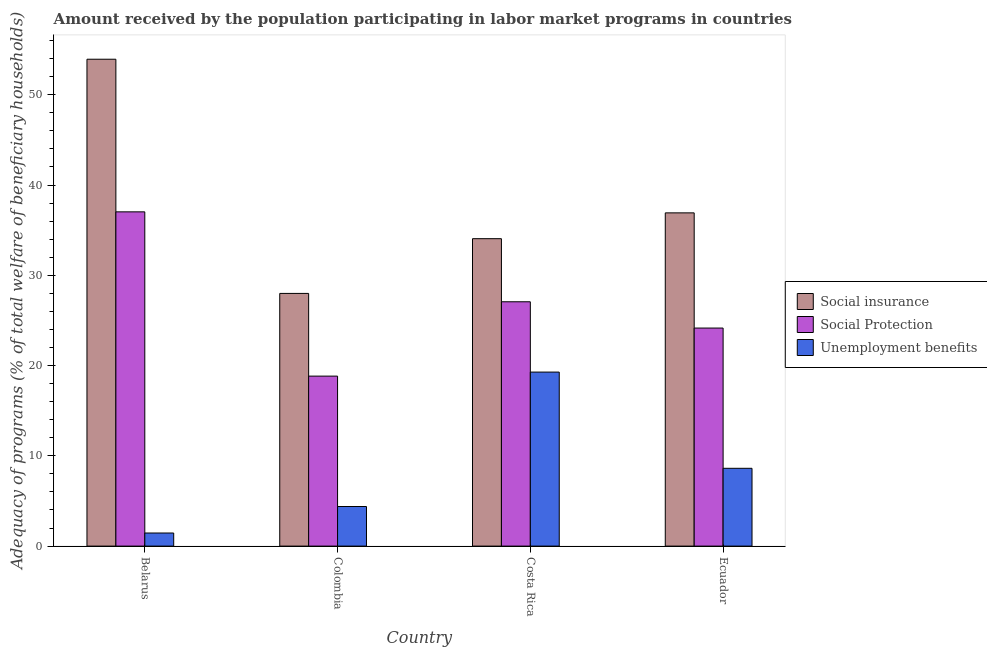How many different coloured bars are there?
Offer a very short reply. 3. How many groups of bars are there?
Your answer should be compact. 4. Are the number of bars per tick equal to the number of legend labels?
Offer a terse response. Yes. How many bars are there on the 2nd tick from the right?
Make the answer very short. 3. What is the label of the 1st group of bars from the left?
Your response must be concise. Belarus. What is the amount received by the population participating in social protection programs in Belarus?
Provide a succinct answer. 37.03. Across all countries, what is the maximum amount received by the population participating in social insurance programs?
Give a very brief answer. 53.93. Across all countries, what is the minimum amount received by the population participating in unemployment benefits programs?
Give a very brief answer. 1.45. In which country was the amount received by the population participating in social protection programs maximum?
Provide a short and direct response. Belarus. In which country was the amount received by the population participating in unemployment benefits programs minimum?
Provide a short and direct response. Belarus. What is the total amount received by the population participating in social insurance programs in the graph?
Your response must be concise. 152.89. What is the difference between the amount received by the population participating in social protection programs in Belarus and that in Ecuador?
Offer a very short reply. 12.87. What is the difference between the amount received by the population participating in social protection programs in Ecuador and the amount received by the population participating in social insurance programs in Belarus?
Provide a short and direct response. -29.78. What is the average amount received by the population participating in unemployment benefits programs per country?
Provide a succinct answer. 8.43. What is the difference between the amount received by the population participating in social protection programs and amount received by the population participating in social insurance programs in Costa Rica?
Your answer should be compact. -6.99. What is the ratio of the amount received by the population participating in social protection programs in Belarus to that in Colombia?
Provide a succinct answer. 1.97. Is the amount received by the population participating in social insurance programs in Belarus less than that in Colombia?
Offer a terse response. No. What is the difference between the highest and the second highest amount received by the population participating in unemployment benefits programs?
Your answer should be compact. 10.66. What is the difference between the highest and the lowest amount received by the population participating in social protection programs?
Keep it short and to the point. 18.2. Is the sum of the amount received by the population participating in unemployment benefits programs in Costa Rica and Ecuador greater than the maximum amount received by the population participating in social protection programs across all countries?
Keep it short and to the point. No. What does the 2nd bar from the left in Costa Rica represents?
Keep it short and to the point. Social Protection. What does the 1st bar from the right in Costa Rica represents?
Your answer should be compact. Unemployment benefits. Is it the case that in every country, the sum of the amount received by the population participating in social insurance programs and amount received by the population participating in social protection programs is greater than the amount received by the population participating in unemployment benefits programs?
Offer a very short reply. Yes. How many bars are there?
Your answer should be very brief. 12. What is the difference between two consecutive major ticks on the Y-axis?
Your answer should be compact. 10. Does the graph contain any zero values?
Your response must be concise. No. Does the graph contain grids?
Your answer should be very brief. No. Where does the legend appear in the graph?
Offer a terse response. Center right. How many legend labels are there?
Your response must be concise. 3. How are the legend labels stacked?
Provide a short and direct response. Vertical. What is the title of the graph?
Your answer should be very brief. Amount received by the population participating in labor market programs in countries. Does "Financial account" appear as one of the legend labels in the graph?
Your response must be concise. No. What is the label or title of the Y-axis?
Give a very brief answer. Adequacy of programs (% of total welfare of beneficiary households). What is the Adequacy of programs (% of total welfare of beneficiary households) in Social insurance in Belarus?
Your answer should be very brief. 53.93. What is the Adequacy of programs (% of total welfare of beneficiary households) in Social Protection in Belarus?
Provide a short and direct response. 37.03. What is the Adequacy of programs (% of total welfare of beneficiary households) in Unemployment benefits in Belarus?
Your response must be concise. 1.45. What is the Adequacy of programs (% of total welfare of beneficiary households) of Social insurance in Colombia?
Give a very brief answer. 27.99. What is the Adequacy of programs (% of total welfare of beneficiary households) in Social Protection in Colombia?
Provide a succinct answer. 18.83. What is the Adequacy of programs (% of total welfare of beneficiary households) in Unemployment benefits in Colombia?
Your answer should be compact. 4.39. What is the Adequacy of programs (% of total welfare of beneficiary households) of Social insurance in Costa Rica?
Keep it short and to the point. 34.05. What is the Adequacy of programs (% of total welfare of beneficiary households) of Social Protection in Costa Rica?
Your answer should be compact. 27.06. What is the Adequacy of programs (% of total welfare of beneficiary households) in Unemployment benefits in Costa Rica?
Make the answer very short. 19.28. What is the Adequacy of programs (% of total welfare of beneficiary households) in Social insurance in Ecuador?
Ensure brevity in your answer.  36.91. What is the Adequacy of programs (% of total welfare of beneficiary households) in Social Protection in Ecuador?
Your response must be concise. 24.15. What is the Adequacy of programs (% of total welfare of beneficiary households) in Unemployment benefits in Ecuador?
Keep it short and to the point. 8.62. Across all countries, what is the maximum Adequacy of programs (% of total welfare of beneficiary households) of Social insurance?
Provide a short and direct response. 53.93. Across all countries, what is the maximum Adequacy of programs (% of total welfare of beneficiary households) of Social Protection?
Offer a very short reply. 37.03. Across all countries, what is the maximum Adequacy of programs (% of total welfare of beneficiary households) of Unemployment benefits?
Give a very brief answer. 19.28. Across all countries, what is the minimum Adequacy of programs (% of total welfare of beneficiary households) of Social insurance?
Your answer should be compact. 27.99. Across all countries, what is the minimum Adequacy of programs (% of total welfare of beneficiary households) in Social Protection?
Offer a very short reply. 18.83. Across all countries, what is the minimum Adequacy of programs (% of total welfare of beneficiary households) in Unemployment benefits?
Make the answer very short. 1.45. What is the total Adequacy of programs (% of total welfare of beneficiary households) of Social insurance in the graph?
Your answer should be compact. 152.89. What is the total Adequacy of programs (% of total welfare of beneficiary households) of Social Protection in the graph?
Provide a short and direct response. 107.07. What is the total Adequacy of programs (% of total welfare of beneficiary households) in Unemployment benefits in the graph?
Keep it short and to the point. 33.73. What is the difference between the Adequacy of programs (% of total welfare of beneficiary households) in Social insurance in Belarus and that in Colombia?
Offer a very short reply. 25.94. What is the difference between the Adequacy of programs (% of total welfare of beneficiary households) of Social Protection in Belarus and that in Colombia?
Your answer should be compact. 18.2. What is the difference between the Adequacy of programs (% of total welfare of beneficiary households) of Unemployment benefits in Belarus and that in Colombia?
Your answer should be very brief. -2.94. What is the difference between the Adequacy of programs (% of total welfare of beneficiary households) of Social insurance in Belarus and that in Costa Rica?
Your response must be concise. 19.88. What is the difference between the Adequacy of programs (% of total welfare of beneficiary households) of Social Protection in Belarus and that in Costa Rica?
Offer a very short reply. 9.96. What is the difference between the Adequacy of programs (% of total welfare of beneficiary households) in Unemployment benefits in Belarus and that in Costa Rica?
Your answer should be compact. -17.83. What is the difference between the Adequacy of programs (% of total welfare of beneficiary households) of Social insurance in Belarus and that in Ecuador?
Provide a succinct answer. 17.02. What is the difference between the Adequacy of programs (% of total welfare of beneficiary households) of Social Protection in Belarus and that in Ecuador?
Give a very brief answer. 12.87. What is the difference between the Adequacy of programs (% of total welfare of beneficiary households) in Unemployment benefits in Belarus and that in Ecuador?
Provide a succinct answer. -7.17. What is the difference between the Adequacy of programs (% of total welfare of beneficiary households) of Social insurance in Colombia and that in Costa Rica?
Offer a terse response. -6.06. What is the difference between the Adequacy of programs (% of total welfare of beneficiary households) in Social Protection in Colombia and that in Costa Rica?
Give a very brief answer. -8.24. What is the difference between the Adequacy of programs (% of total welfare of beneficiary households) in Unemployment benefits in Colombia and that in Costa Rica?
Make the answer very short. -14.89. What is the difference between the Adequacy of programs (% of total welfare of beneficiary households) in Social insurance in Colombia and that in Ecuador?
Offer a very short reply. -8.92. What is the difference between the Adequacy of programs (% of total welfare of beneficiary households) of Social Protection in Colombia and that in Ecuador?
Offer a terse response. -5.33. What is the difference between the Adequacy of programs (% of total welfare of beneficiary households) in Unemployment benefits in Colombia and that in Ecuador?
Your response must be concise. -4.23. What is the difference between the Adequacy of programs (% of total welfare of beneficiary households) of Social insurance in Costa Rica and that in Ecuador?
Keep it short and to the point. -2.86. What is the difference between the Adequacy of programs (% of total welfare of beneficiary households) of Social Protection in Costa Rica and that in Ecuador?
Provide a succinct answer. 2.91. What is the difference between the Adequacy of programs (% of total welfare of beneficiary households) of Unemployment benefits in Costa Rica and that in Ecuador?
Keep it short and to the point. 10.66. What is the difference between the Adequacy of programs (% of total welfare of beneficiary households) of Social insurance in Belarus and the Adequacy of programs (% of total welfare of beneficiary households) of Social Protection in Colombia?
Offer a very short reply. 35.1. What is the difference between the Adequacy of programs (% of total welfare of beneficiary households) of Social insurance in Belarus and the Adequacy of programs (% of total welfare of beneficiary households) of Unemployment benefits in Colombia?
Ensure brevity in your answer.  49.55. What is the difference between the Adequacy of programs (% of total welfare of beneficiary households) of Social Protection in Belarus and the Adequacy of programs (% of total welfare of beneficiary households) of Unemployment benefits in Colombia?
Ensure brevity in your answer.  32.64. What is the difference between the Adequacy of programs (% of total welfare of beneficiary households) in Social insurance in Belarus and the Adequacy of programs (% of total welfare of beneficiary households) in Social Protection in Costa Rica?
Make the answer very short. 26.87. What is the difference between the Adequacy of programs (% of total welfare of beneficiary households) of Social insurance in Belarus and the Adequacy of programs (% of total welfare of beneficiary households) of Unemployment benefits in Costa Rica?
Provide a short and direct response. 34.66. What is the difference between the Adequacy of programs (% of total welfare of beneficiary households) of Social Protection in Belarus and the Adequacy of programs (% of total welfare of beneficiary households) of Unemployment benefits in Costa Rica?
Offer a terse response. 17.75. What is the difference between the Adequacy of programs (% of total welfare of beneficiary households) in Social insurance in Belarus and the Adequacy of programs (% of total welfare of beneficiary households) in Social Protection in Ecuador?
Offer a very short reply. 29.78. What is the difference between the Adequacy of programs (% of total welfare of beneficiary households) of Social insurance in Belarus and the Adequacy of programs (% of total welfare of beneficiary households) of Unemployment benefits in Ecuador?
Your answer should be compact. 45.32. What is the difference between the Adequacy of programs (% of total welfare of beneficiary households) of Social Protection in Belarus and the Adequacy of programs (% of total welfare of beneficiary households) of Unemployment benefits in Ecuador?
Provide a succinct answer. 28.41. What is the difference between the Adequacy of programs (% of total welfare of beneficiary households) in Social insurance in Colombia and the Adequacy of programs (% of total welfare of beneficiary households) in Social Protection in Costa Rica?
Offer a very short reply. 0.93. What is the difference between the Adequacy of programs (% of total welfare of beneficiary households) of Social insurance in Colombia and the Adequacy of programs (% of total welfare of beneficiary households) of Unemployment benefits in Costa Rica?
Your answer should be compact. 8.72. What is the difference between the Adequacy of programs (% of total welfare of beneficiary households) of Social Protection in Colombia and the Adequacy of programs (% of total welfare of beneficiary households) of Unemployment benefits in Costa Rica?
Provide a short and direct response. -0.45. What is the difference between the Adequacy of programs (% of total welfare of beneficiary households) in Social insurance in Colombia and the Adequacy of programs (% of total welfare of beneficiary households) in Social Protection in Ecuador?
Provide a short and direct response. 3.84. What is the difference between the Adequacy of programs (% of total welfare of beneficiary households) of Social insurance in Colombia and the Adequacy of programs (% of total welfare of beneficiary households) of Unemployment benefits in Ecuador?
Give a very brief answer. 19.37. What is the difference between the Adequacy of programs (% of total welfare of beneficiary households) of Social Protection in Colombia and the Adequacy of programs (% of total welfare of beneficiary households) of Unemployment benefits in Ecuador?
Provide a succinct answer. 10.21. What is the difference between the Adequacy of programs (% of total welfare of beneficiary households) in Social insurance in Costa Rica and the Adequacy of programs (% of total welfare of beneficiary households) in Social Protection in Ecuador?
Offer a very short reply. 9.9. What is the difference between the Adequacy of programs (% of total welfare of beneficiary households) of Social insurance in Costa Rica and the Adequacy of programs (% of total welfare of beneficiary households) of Unemployment benefits in Ecuador?
Ensure brevity in your answer.  25.44. What is the difference between the Adequacy of programs (% of total welfare of beneficiary households) of Social Protection in Costa Rica and the Adequacy of programs (% of total welfare of beneficiary households) of Unemployment benefits in Ecuador?
Offer a very short reply. 18.45. What is the average Adequacy of programs (% of total welfare of beneficiary households) in Social insurance per country?
Your answer should be very brief. 38.22. What is the average Adequacy of programs (% of total welfare of beneficiary households) of Social Protection per country?
Your answer should be compact. 26.77. What is the average Adequacy of programs (% of total welfare of beneficiary households) of Unemployment benefits per country?
Offer a terse response. 8.43. What is the difference between the Adequacy of programs (% of total welfare of beneficiary households) in Social insurance and Adequacy of programs (% of total welfare of beneficiary households) in Social Protection in Belarus?
Give a very brief answer. 16.91. What is the difference between the Adequacy of programs (% of total welfare of beneficiary households) of Social insurance and Adequacy of programs (% of total welfare of beneficiary households) of Unemployment benefits in Belarus?
Give a very brief answer. 52.48. What is the difference between the Adequacy of programs (% of total welfare of beneficiary households) in Social Protection and Adequacy of programs (% of total welfare of beneficiary households) in Unemployment benefits in Belarus?
Provide a short and direct response. 35.58. What is the difference between the Adequacy of programs (% of total welfare of beneficiary households) of Social insurance and Adequacy of programs (% of total welfare of beneficiary households) of Social Protection in Colombia?
Your response must be concise. 9.16. What is the difference between the Adequacy of programs (% of total welfare of beneficiary households) of Social insurance and Adequacy of programs (% of total welfare of beneficiary households) of Unemployment benefits in Colombia?
Ensure brevity in your answer.  23.61. What is the difference between the Adequacy of programs (% of total welfare of beneficiary households) in Social Protection and Adequacy of programs (% of total welfare of beneficiary households) in Unemployment benefits in Colombia?
Your answer should be very brief. 14.44. What is the difference between the Adequacy of programs (% of total welfare of beneficiary households) of Social insurance and Adequacy of programs (% of total welfare of beneficiary households) of Social Protection in Costa Rica?
Keep it short and to the point. 6.99. What is the difference between the Adequacy of programs (% of total welfare of beneficiary households) in Social insurance and Adequacy of programs (% of total welfare of beneficiary households) in Unemployment benefits in Costa Rica?
Ensure brevity in your answer.  14.78. What is the difference between the Adequacy of programs (% of total welfare of beneficiary households) of Social Protection and Adequacy of programs (% of total welfare of beneficiary households) of Unemployment benefits in Costa Rica?
Give a very brief answer. 7.79. What is the difference between the Adequacy of programs (% of total welfare of beneficiary households) in Social insurance and Adequacy of programs (% of total welfare of beneficiary households) in Social Protection in Ecuador?
Provide a succinct answer. 12.76. What is the difference between the Adequacy of programs (% of total welfare of beneficiary households) of Social insurance and Adequacy of programs (% of total welfare of beneficiary households) of Unemployment benefits in Ecuador?
Your response must be concise. 28.3. What is the difference between the Adequacy of programs (% of total welfare of beneficiary households) of Social Protection and Adequacy of programs (% of total welfare of beneficiary households) of Unemployment benefits in Ecuador?
Your answer should be very brief. 15.54. What is the ratio of the Adequacy of programs (% of total welfare of beneficiary households) in Social insurance in Belarus to that in Colombia?
Your response must be concise. 1.93. What is the ratio of the Adequacy of programs (% of total welfare of beneficiary households) in Social Protection in Belarus to that in Colombia?
Your answer should be very brief. 1.97. What is the ratio of the Adequacy of programs (% of total welfare of beneficiary households) in Unemployment benefits in Belarus to that in Colombia?
Provide a short and direct response. 0.33. What is the ratio of the Adequacy of programs (% of total welfare of beneficiary households) in Social insurance in Belarus to that in Costa Rica?
Make the answer very short. 1.58. What is the ratio of the Adequacy of programs (% of total welfare of beneficiary households) of Social Protection in Belarus to that in Costa Rica?
Give a very brief answer. 1.37. What is the ratio of the Adequacy of programs (% of total welfare of beneficiary households) in Unemployment benefits in Belarus to that in Costa Rica?
Ensure brevity in your answer.  0.08. What is the ratio of the Adequacy of programs (% of total welfare of beneficiary households) in Social insurance in Belarus to that in Ecuador?
Provide a succinct answer. 1.46. What is the ratio of the Adequacy of programs (% of total welfare of beneficiary households) of Social Protection in Belarus to that in Ecuador?
Your answer should be compact. 1.53. What is the ratio of the Adequacy of programs (% of total welfare of beneficiary households) in Unemployment benefits in Belarus to that in Ecuador?
Your answer should be very brief. 0.17. What is the ratio of the Adequacy of programs (% of total welfare of beneficiary households) of Social insurance in Colombia to that in Costa Rica?
Provide a succinct answer. 0.82. What is the ratio of the Adequacy of programs (% of total welfare of beneficiary households) of Social Protection in Colombia to that in Costa Rica?
Ensure brevity in your answer.  0.7. What is the ratio of the Adequacy of programs (% of total welfare of beneficiary households) of Unemployment benefits in Colombia to that in Costa Rica?
Give a very brief answer. 0.23. What is the ratio of the Adequacy of programs (% of total welfare of beneficiary households) in Social insurance in Colombia to that in Ecuador?
Your answer should be compact. 0.76. What is the ratio of the Adequacy of programs (% of total welfare of beneficiary households) in Social Protection in Colombia to that in Ecuador?
Provide a succinct answer. 0.78. What is the ratio of the Adequacy of programs (% of total welfare of beneficiary households) of Unemployment benefits in Colombia to that in Ecuador?
Make the answer very short. 0.51. What is the ratio of the Adequacy of programs (% of total welfare of beneficiary households) in Social insurance in Costa Rica to that in Ecuador?
Your answer should be very brief. 0.92. What is the ratio of the Adequacy of programs (% of total welfare of beneficiary households) in Social Protection in Costa Rica to that in Ecuador?
Offer a very short reply. 1.12. What is the ratio of the Adequacy of programs (% of total welfare of beneficiary households) in Unemployment benefits in Costa Rica to that in Ecuador?
Keep it short and to the point. 2.24. What is the difference between the highest and the second highest Adequacy of programs (% of total welfare of beneficiary households) in Social insurance?
Your response must be concise. 17.02. What is the difference between the highest and the second highest Adequacy of programs (% of total welfare of beneficiary households) in Social Protection?
Your answer should be compact. 9.96. What is the difference between the highest and the second highest Adequacy of programs (% of total welfare of beneficiary households) in Unemployment benefits?
Your answer should be compact. 10.66. What is the difference between the highest and the lowest Adequacy of programs (% of total welfare of beneficiary households) of Social insurance?
Offer a very short reply. 25.94. What is the difference between the highest and the lowest Adequacy of programs (% of total welfare of beneficiary households) of Social Protection?
Provide a succinct answer. 18.2. What is the difference between the highest and the lowest Adequacy of programs (% of total welfare of beneficiary households) of Unemployment benefits?
Your answer should be compact. 17.83. 